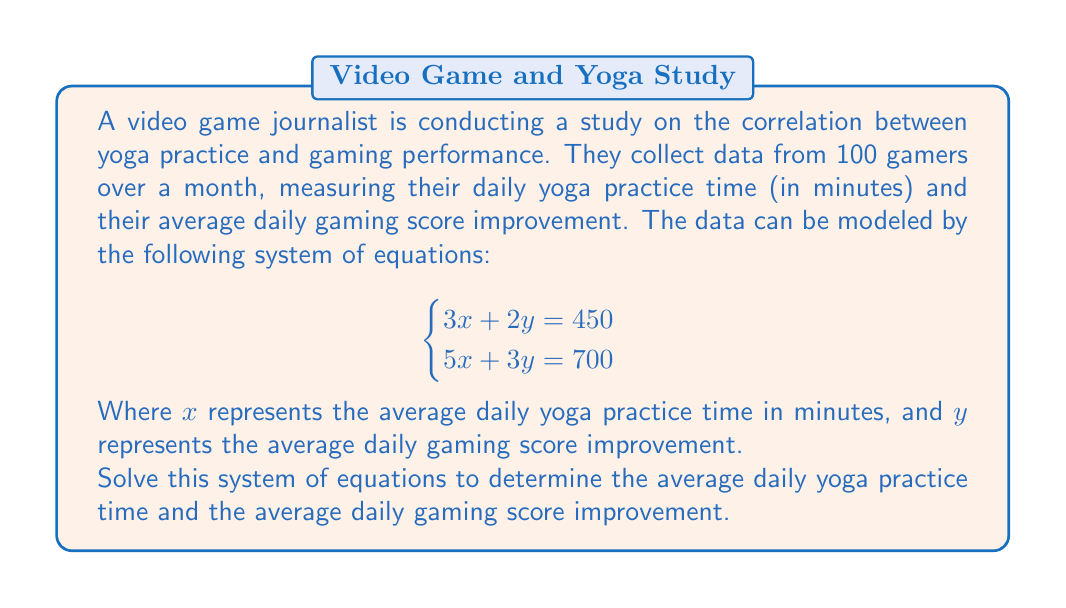Give your solution to this math problem. To solve this system of equations, we'll use the elimination method:

1) First, multiply the first equation by 3 and the second equation by 2:

   $$\begin{cases}
   9x + 6y = 1350 \\
   10x + 6y = 1400
   \end{cases}$$

2) Subtract the first equation from the second:

   $x = 50$

3) Substitute this value of $x$ into either of the original equations. Let's use the first one:

   $$3(50) + 2y = 450$$
   $$150 + 2y = 450$$
   $$2y = 300$$
   $$y = 150$$

4) Therefore, $x = 50$ and $y = 150$

5) Interpret the results:
   - The average daily yoga practice time is 50 minutes.
   - The average daily gaming score improvement is 150 points.

This solution suggests a positive correlation between yoga practice and gaming performance improvement, which aligns with the concept of mindfulness enhancing focus and cognitive abilities in gaming.
Answer: $x = 50$, $y = 150$

The average daily yoga practice time is 50 minutes, and the average daily gaming score improvement is 150 points. 